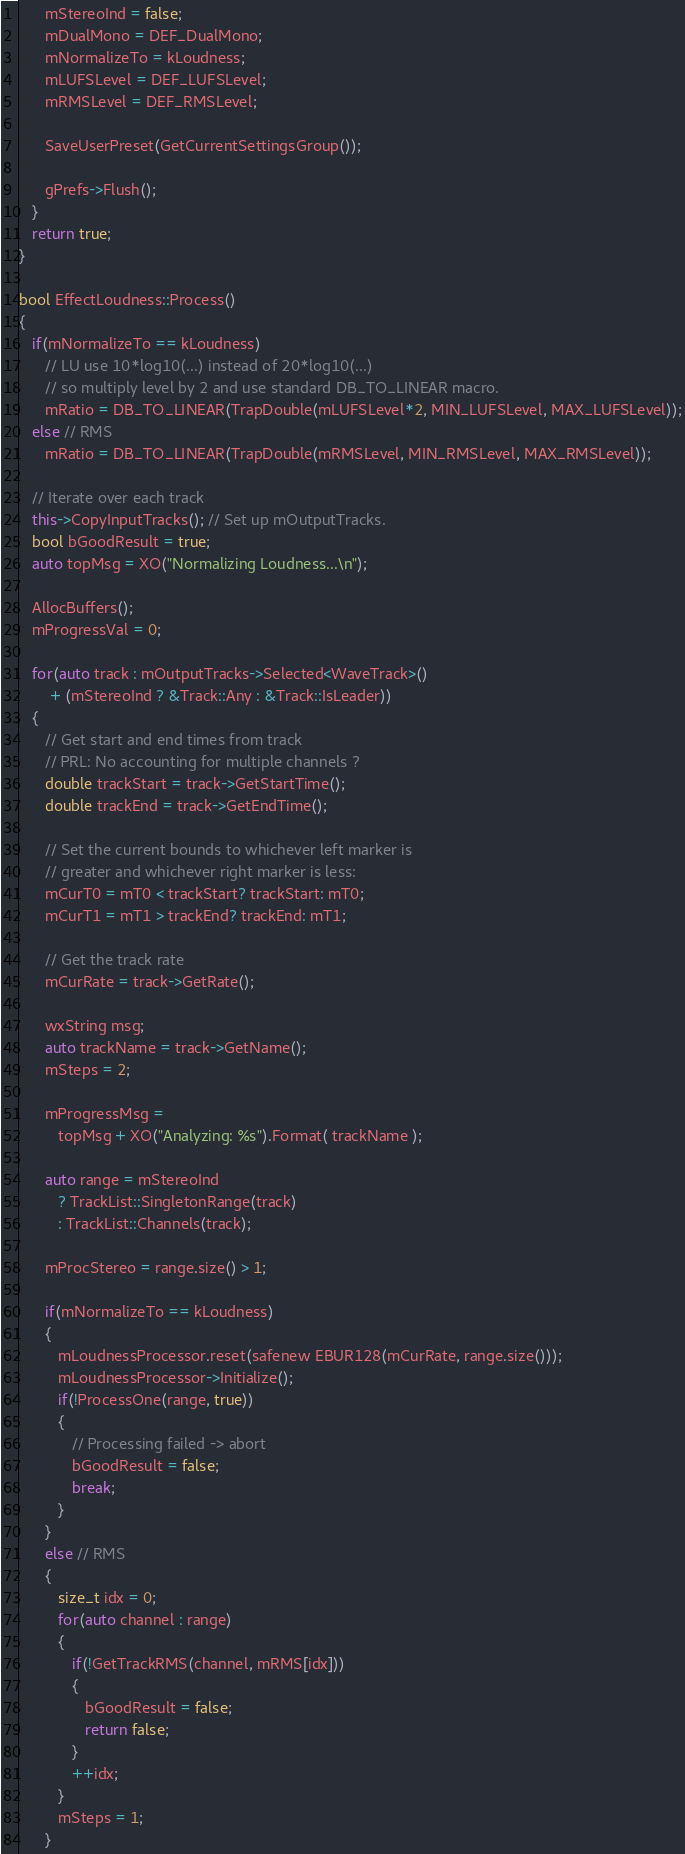Convert code to text. <code><loc_0><loc_0><loc_500><loc_500><_C++_>      mStereoInd = false;
      mDualMono = DEF_DualMono;
      mNormalizeTo = kLoudness;
      mLUFSLevel = DEF_LUFSLevel;
      mRMSLevel = DEF_RMSLevel;

      SaveUserPreset(GetCurrentSettingsGroup());

      gPrefs->Flush();
   }
   return true;
}

bool EffectLoudness::Process()
{
   if(mNormalizeTo == kLoudness)
      // LU use 10*log10(...) instead of 20*log10(...)
      // so multiply level by 2 and use standard DB_TO_LINEAR macro.
      mRatio = DB_TO_LINEAR(TrapDouble(mLUFSLevel*2, MIN_LUFSLevel, MAX_LUFSLevel));
   else // RMS
      mRatio = DB_TO_LINEAR(TrapDouble(mRMSLevel, MIN_RMSLevel, MAX_RMSLevel));

   // Iterate over each track
   this->CopyInputTracks(); // Set up mOutputTracks.
   bool bGoodResult = true;
   auto topMsg = XO("Normalizing Loudness...\n");

   AllocBuffers();
   mProgressVal = 0;

   for(auto track : mOutputTracks->Selected<WaveTrack>()
       + (mStereoInd ? &Track::Any : &Track::IsLeader))
   {
      // Get start and end times from track
      // PRL: No accounting for multiple channels ?
      double trackStart = track->GetStartTime();
      double trackEnd = track->GetEndTime();

      // Set the current bounds to whichever left marker is
      // greater and whichever right marker is less:
      mCurT0 = mT0 < trackStart? trackStart: mT0;
      mCurT1 = mT1 > trackEnd? trackEnd: mT1;

      // Get the track rate
      mCurRate = track->GetRate();

      wxString msg;
      auto trackName = track->GetName();
      mSteps = 2;

      mProgressMsg =
         topMsg + XO("Analyzing: %s").Format( trackName );

      auto range = mStereoInd
         ? TrackList::SingletonRange(track)
         : TrackList::Channels(track);

      mProcStereo = range.size() > 1;

      if(mNormalizeTo == kLoudness)
      {
         mLoudnessProcessor.reset(safenew EBUR128(mCurRate, range.size()));
         mLoudnessProcessor->Initialize();
         if(!ProcessOne(range, true))
         {
            // Processing failed -> abort
            bGoodResult = false;
            break;
         }
      }
      else // RMS
      {
         size_t idx = 0;
         for(auto channel : range)
         {
            if(!GetTrackRMS(channel, mRMS[idx]))
            {
               bGoodResult = false;
               return false;
            }
            ++idx;
         }
         mSteps = 1;
      }
</code> 